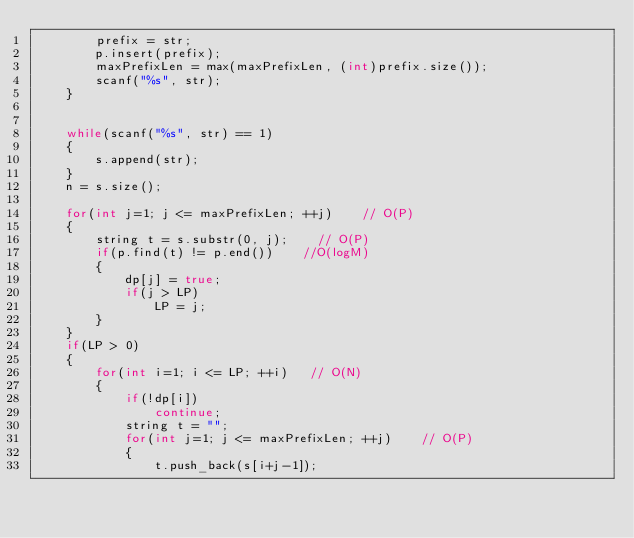<code> <loc_0><loc_0><loc_500><loc_500><_C++_>        prefix = str;
        p.insert(prefix);
        maxPrefixLen = max(maxPrefixLen, (int)prefix.size());
        scanf("%s", str);
    }

    
    while(scanf("%s", str) == 1)
    {
        s.append(str);
    }
    n = s.size();

    for(int j=1; j <= maxPrefixLen; ++j)    // O(P)
    {
        string t = s.substr(0, j);    // O(P)
        if(p.find(t) != p.end())    //O(logM)
        {
            dp[j] = true;
            if(j > LP)
                LP = j;
        }
    }
    if(LP > 0)
    {
        for(int i=1; i <= LP; ++i)   // O(N)
        {
            if(!dp[i])
                continue;
            string t = "";
            for(int j=1; j <= maxPrefixLen; ++j)    // O(P)
            {
                t.push_back(s[i+j-1]);</code> 